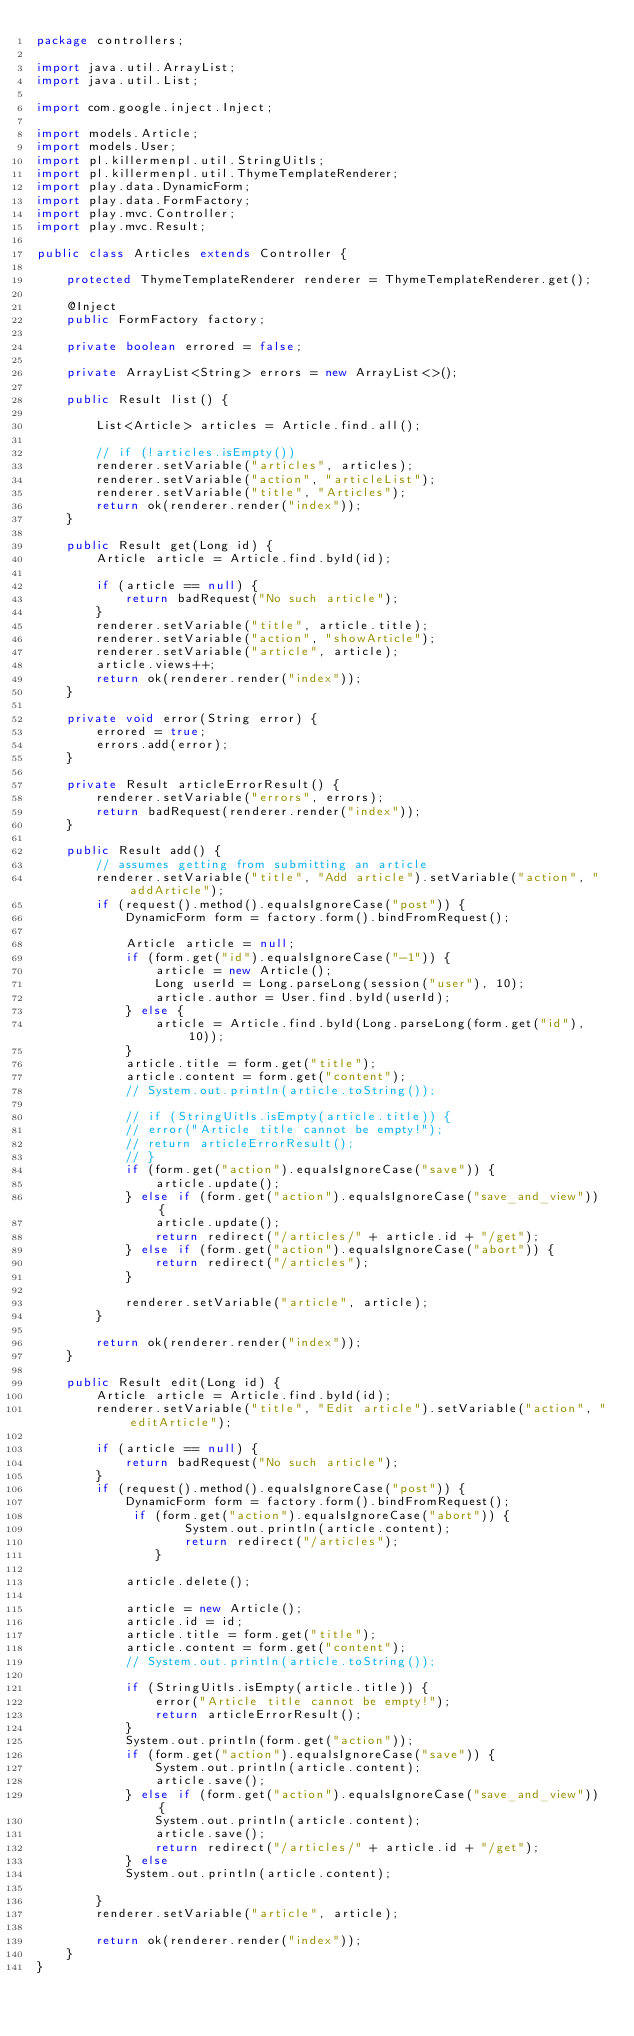Convert code to text. <code><loc_0><loc_0><loc_500><loc_500><_Java_>package controllers;

import java.util.ArrayList;
import java.util.List;

import com.google.inject.Inject;

import models.Article;
import models.User;
import pl.killermenpl.util.StringUitls;
import pl.killermenpl.util.ThymeTemplateRenderer;
import play.data.DynamicForm;
import play.data.FormFactory;
import play.mvc.Controller;
import play.mvc.Result;

public class Articles extends Controller {

	protected ThymeTemplateRenderer renderer = ThymeTemplateRenderer.get();

	@Inject
	public FormFactory factory;

	private boolean errored = false;

	private ArrayList<String> errors = new ArrayList<>();

	public Result list() {

		List<Article> articles = Article.find.all();

		// if (!articles.isEmpty())
		renderer.setVariable("articles", articles);
		renderer.setVariable("action", "articleList");
		renderer.setVariable("title", "Articles");
		return ok(renderer.render("index"));
	}

	public Result get(Long id) {
		Article article = Article.find.byId(id);

		if (article == null) {
			return badRequest("No such article");
		}
		renderer.setVariable("title", article.title);
		renderer.setVariable("action", "showArticle");
		renderer.setVariable("article", article);
		article.views++;
		return ok(renderer.render("index"));
	}

	private void error(String error) {
		errored = true;
		errors.add(error);
	}

	private Result articleErrorResult() {
		renderer.setVariable("errors", errors);
		return badRequest(renderer.render("index"));
	}

	public Result add() {
		// assumes getting from submitting an article
		renderer.setVariable("title", "Add article").setVariable("action", "addArticle");
		if (request().method().equalsIgnoreCase("post")) {
			DynamicForm form = factory.form().bindFromRequest();

			Article article = null;
			if (form.get("id").equalsIgnoreCase("-1")) {
				article = new Article();
				Long userId = Long.parseLong(session("user"), 10);
				article.author = User.find.byId(userId);
			} else {
				article = Article.find.byId(Long.parseLong(form.get("id"), 10));
			}
			article.title = form.get("title");
			article.content = form.get("content");
			// System.out.println(article.toString());

			// if (StringUitls.isEmpty(article.title)) {
			// error("Article title cannot be empty!");
			// return articleErrorResult();
			// }
			if (form.get("action").equalsIgnoreCase("save")) {
				article.update();
			} else if (form.get("action").equalsIgnoreCase("save_and_view")) {
				article.update();
				return redirect("/articles/" + article.id + "/get");
			} else if (form.get("action").equalsIgnoreCase("abort")) {
				return redirect("/articles");
			}

			renderer.setVariable("article", article);
		}

		return ok(renderer.render("index"));
	}

	public Result edit(Long id) {
		Article article = Article.find.byId(id);
		renderer.setVariable("title", "Edit article").setVariable("action", "editArticle");
		
		if (article == null) {
			return badRequest("No such article");
		}
		if (request().method().equalsIgnoreCase("post")) {
			DynamicForm form = factory.form().bindFromRequest();
			 if (form.get("action").equalsIgnoreCase("abort")) {
					System.out.println(article.content);
					return redirect("/articles");
				}
			
			article.delete();
			
			article = new Article();
			article.id = id;
			article.title = form.get("title");
			article.content = form.get("content");
			// System.out.println(article.toString());

			if (StringUitls.isEmpty(article.title)) {
				error("Article title cannot be empty!");
				return articleErrorResult();
			}
			System.out.println(form.get("action"));
			if (form.get("action").equalsIgnoreCase("save")) {
				System.out.println(article.content);
				article.save();
			} else if (form.get("action").equalsIgnoreCase("save_and_view")) {
				System.out.println(article.content);
				article.save();
				return redirect("/articles/" + article.id + "/get");
			} else
			System.out.println(article.content);

		}
		renderer.setVariable("article", article);

		return ok(renderer.render("index"));
	}
}
</code> 